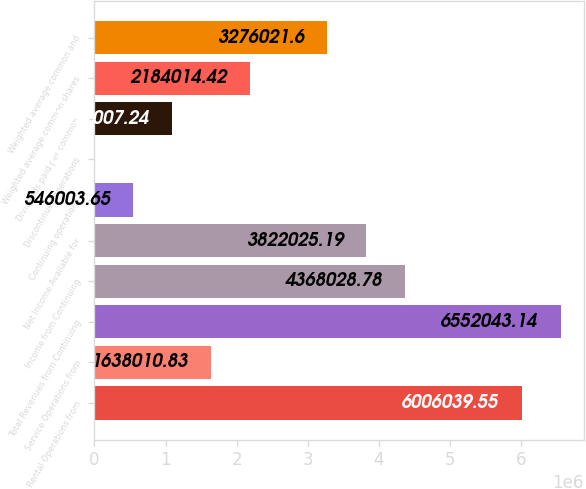Convert chart. <chart><loc_0><loc_0><loc_500><loc_500><bar_chart><fcel>Rental Operations from<fcel>Service Operations from<fcel>Total Revenues from Continuing<fcel>Income from Continuing<fcel>Net Income Available for<fcel>Continuing operations<fcel>Discontinued operations<fcel>Dividends paid per common<fcel>Weighted average common shares<fcel>Weighted average common and<nl><fcel>6.00604e+06<fcel>1.63801e+06<fcel>6.55204e+06<fcel>4.36803e+06<fcel>3.82203e+06<fcel>546004<fcel>0.06<fcel>1.09201e+06<fcel>2.18401e+06<fcel>3.27602e+06<nl></chart> 